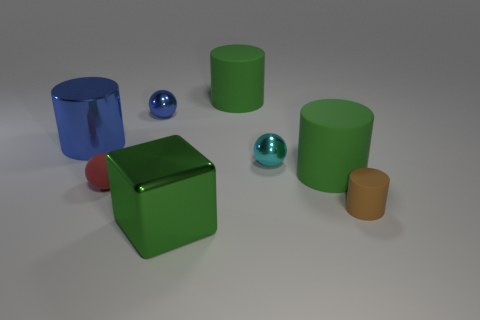Subtract all cyan balls. Subtract all purple cylinders. How many balls are left? 2 Add 2 tiny blue metal spheres. How many objects exist? 10 Subtract all cubes. How many objects are left? 7 Add 5 big red blocks. How many big red blocks exist? 5 Subtract 0 purple cubes. How many objects are left? 8 Subtract all big green matte objects. Subtract all blue things. How many objects are left? 4 Add 4 blue things. How many blue things are left? 6 